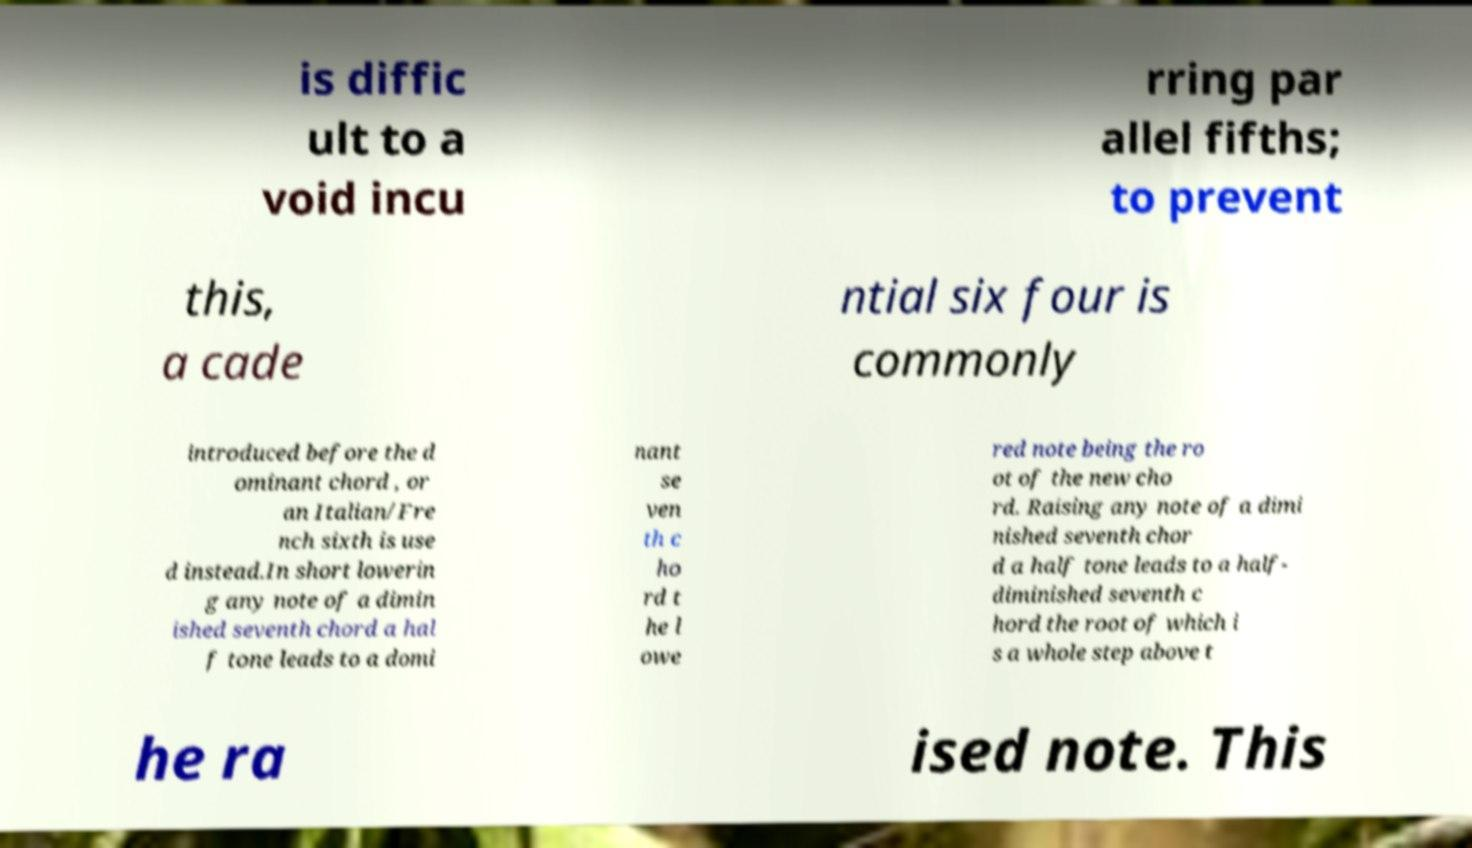What messages or text are displayed in this image? I need them in a readable, typed format. is diffic ult to a void incu rring par allel fifths; to prevent this, a cade ntial six four is commonly introduced before the d ominant chord , or an Italian/Fre nch sixth is use d instead.In short lowerin g any note of a dimin ished seventh chord a hal f tone leads to a domi nant se ven th c ho rd t he l owe red note being the ro ot of the new cho rd. Raising any note of a dimi nished seventh chor d a half tone leads to a half- diminished seventh c hord the root of which i s a whole step above t he ra ised note. This 